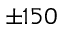<formula> <loc_0><loc_0><loc_500><loc_500>\pm 1 5 0</formula> 